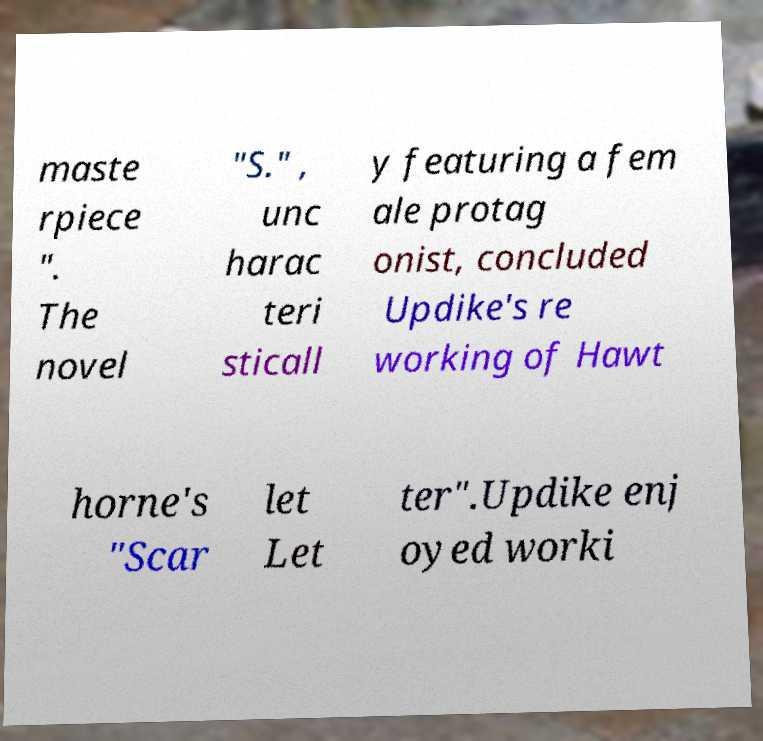I need the written content from this picture converted into text. Can you do that? maste rpiece ". The novel "S." , unc harac teri sticall y featuring a fem ale protag onist, concluded Updike's re working of Hawt horne's "Scar let Let ter".Updike enj oyed worki 